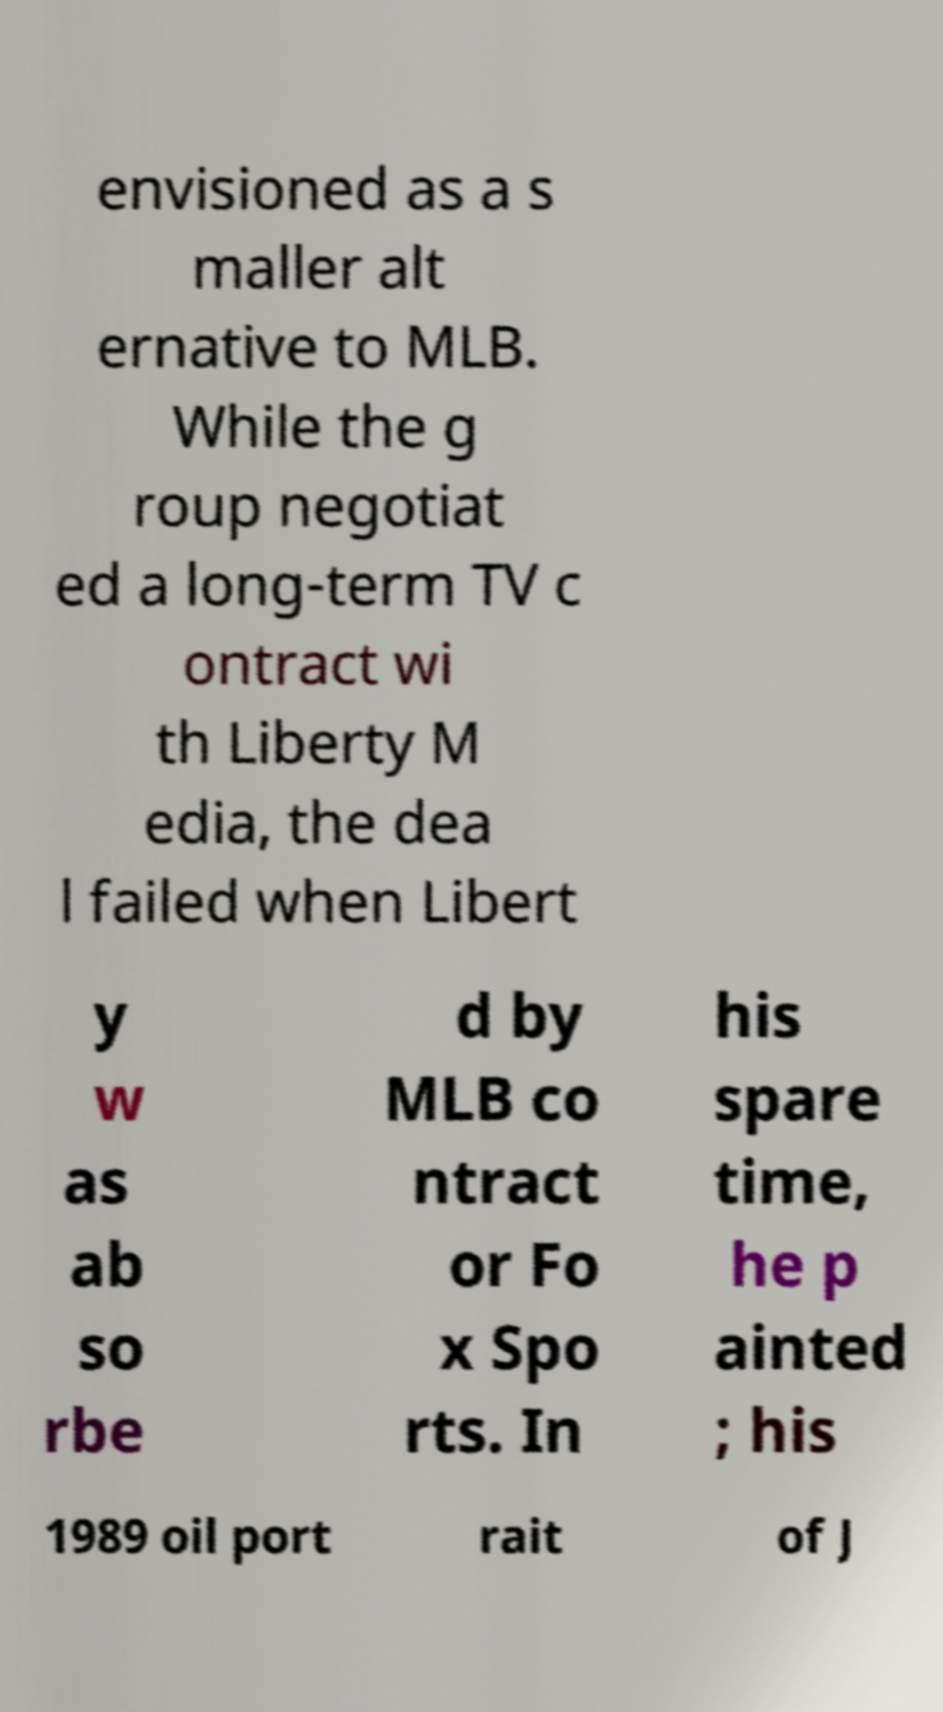Please read and relay the text visible in this image. What does it say? envisioned as a s maller alt ernative to MLB. While the g roup negotiat ed a long-term TV c ontract wi th Liberty M edia, the dea l failed when Libert y w as ab so rbe d by MLB co ntract or Fo x Spo rts. In his spare time, he p ainted ; his 1989 oil port rait of J 